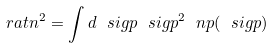<formula> <loc_0><loc_0><loc_500><loc_500>\ r a t n ^ { 2 } = \int d \ s i g p \ s i g p ^ { 2 } \ n p ( \ s i g p )</formula> 